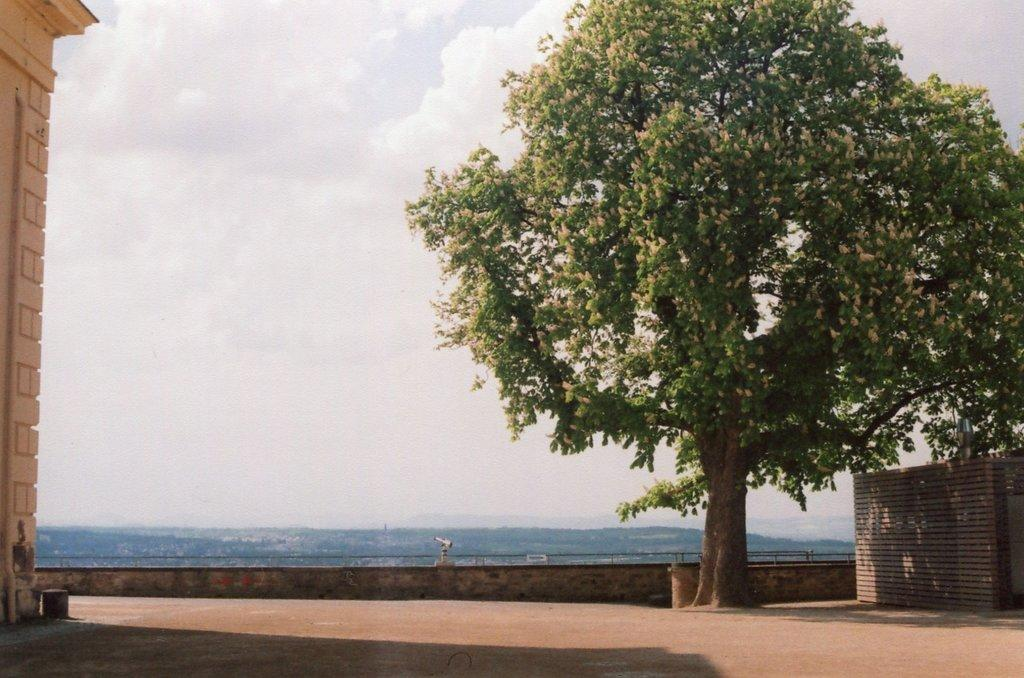What type of natural element is present in the image? There is a tree in the image. What man-made structure can be seen in the image? There is a wall in the image. Can you describe the object in the right bottom corner of the image? The object in the right bottom corner of the image is not specified, but it is present. What is visible in the background of the image? The sky is visible in the image. What device is used for observing distant objects in the image? There is a binocular in the image. What type of bag is hanging on the tree in the image? There is no bag hanging on the tree in the image; only a tree and a wall are mentioned. How does the person in the image express disgust? There is no person present in the image, so it is not possible to determine if they express disgust or feel disgust. 